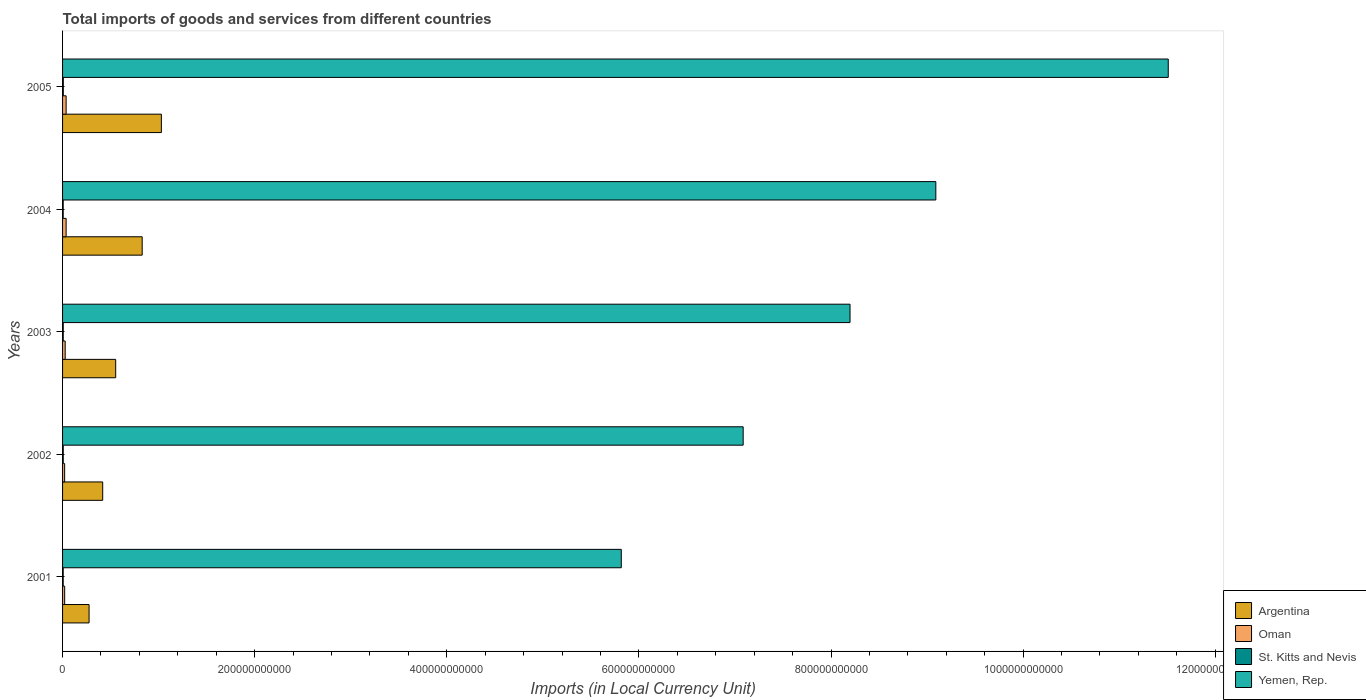How many groups of bars are there?
Provide a succinct answer. 5. How many bars are there on the 5th tick from the top?
Keep it short and to the point. 4. What is the label of the 4th group of bars from the top?
Ensure brevity in your answer.  2002. What is the Amount of goods and services imports in Argentina in 2003?
Make the answer very short. 5.53e+1. Across all years, what is the maximum Amount of goods and services imports in Argentina?
Keep it short and to the point. 1.03e+11. Across all years, what is the minimum Amount of goods and services imports in St. Kitts and Nevis?
Your response must be concise. 6.52e+08. In which year was the Amount of goods and services imports in Oman maximum?
Your answer should be very brief. 2005. In which year was the Amount of goods and services imports in Yemen, Rep. minimum?
Make the answer very short. 2001. What is the total Amount of goods and services imports in Oman in the graph?
Your answer should be compact. 1.45e+1. What is the difference between the Amount of goods and services imports in Oman in 2003 and that in 2005?
Offer a very short reply. -9.84e+08. What is the difference between the Amount of goods and services imports in Oman in 2005 and the Amount of goods and services imports in Argentina in 2003?
Your answer should be very brief. -5.16e+1. What is the average Amount of goods and services imports in St. Kitts and Nevis per year?
Your answer should be very brief. 6.89e+08. In the year 2004, what is the difference between the Amount of goods and services imports in Oman and Amount of goods and services imports in Argentina?
Ensure brevity in your answer.  -7.92e+1. In how many years, is the Amount of goods and services imports in Argentina greater than 560000000000 LCU?
Your answer should be compact. 0. What is the ratio of the Amount of goods and services imports in Oman in 2001 to that in 2003?
Provide a short and direct response. 0.8. What is the difference between the highest and the second highest Amount of goods and services imports in Oman?
Give a very brief answer. 1.10e+07. What is the difference between the highest and the lowest Amount of goods and services imports in Oman?
Give a very brief answer. 1.55e+09. Is it the case that in every year, the sum of the Amount of goods and services imports in Argentina and Amount of goods and services imports in Oman is greater than the sum of Amount of goods and services imports in Yemen, Rep. and Amount of goods and services imports in St. Kitts and Nevis?
Offer a very short reply. No. What does the 1st bar from the top in 2004 represents?
Provide a short and direct response. Yemen, Rep. What does the 4th bar from the bottom in 2004 represents?
Your answer should be compact. Yemen, Rep. Is it the case that in every year, the sum of the Amount of goods and services imports in Argentina and Amount of goods and services imports in St. Kitts and Nevis is greater than the Amount of goods and services imports in Oman?
Keep it short and to the point. Yes. How many bars are there?
Your answer should be very brief. 20. What is the difference between two consecutive major ticks on the X-axis?
Ensure brevity in your answer.  2.00e+11. Are the values on the major ticks of X-axis written in scientific E-notation?
Your answer should be compact. No. How many legend labels are there?
Your answer should be very brief. 4. How are the legend labels stacked?
Your answer should be compact. Vertical. What is the title of the graph?
Your response must be concise. Total imports of goods and services from different countries. Does "Philippines" appear as one of the legend labels in the graph?
Give a very brief answer. No. What is the label or title of the X-axis?
Your response must be concise. Imports (in Local Currency Unit). What is the Imports (in Local Currency Unit) of Argentina in 2001?
Provide a short and direct response. 2.76e+1. What is the Imports (in Local Currency Unit) of Oman in 2001?
Your answer should be compact. 2.19e+09. What is the Imports (in Local Currency Unit) in St. Kitts and Nevis in 2001?
Keep it short and to the point. 6.53e+08. What is the Imports (in Local Currency Unit) in Yemen, Rep. in 2001?
Your answer should be very brief. 5.82e+11. What is the Imports (in Local Currency Unit) of Argentina in 2002?
Make the answer very short. 4.18e+1. What is the Imports (in Local Currency Unit) of Oman in 2002?
Ensure brevity in your answer.  2.16e+09. What is the Imports (in Local Currency Unit) in St. Kitts and Nevis in 2002?
Your answer should be compact. 6.92e+08. What is the Imports (in Local Currency Unit) of Yemen, Rep. in 2002?
Your response must be concise. 7.09e+11. What is the Imports (in Local Currency Unit) of Argentina in 2003?
Your answer should be compact. 5.53e+1. What is the Imports (in Local Currency Unit) in Oman in 2003?
Keep it short and to the point. 2.73e+09. What is the Imports (in Local Currency Unit) in St. Kitts and Nevis in 2003?
Ensure brevity in your answer.  6.91e+08. What is the Imports (in Local Currency Unit) of Yemen, Rep. in 2003?
Your response must be concise. 8.20e+11. What is the Imports (in Local Currency Unit) of Argentina in 2004?
Your answer should be very brief. 8.29e+1. What is the Imports (in Local Currency Unit) of Oman in 2004?
Your response must be concise. 3.70e+09. What is the Imports (in Local Currency Unit) of St. Kitts and Nevis in 2004?
Make the answer very short. 6.52e+08. What is the Imports (in Local Currency Unit) of Yemen, Rep. in 2004?
Your answer should be very brief. 9.09e+11. What is the Imports (in Local Currency Unit) of Argentina in 2005?
Provide a succinct answer. 1.03e+11. What is the Imports (in Local Currency Unit) in Oman in 2005?
Your answer should be very brief. 3.71e+09. What is the Imports (in Local Currency Unit) in St. Kitts and Nevis in 2005?
Offer a very short reply. 7.56e+08. What is the Imports (in Local Currency Unit) in Yemen, Rep. in 2005?
Keep it short and to the point. 1.15e+12. Across all years, what is the maximum Imports (in Local Currency Unit) of Argentina?
Your answer should be very brief. 1.03e+11. Across all years, what is the maximum Imports (in Local Currency Unit) in Oman?
Your response must be concise. 3.71e+09. Across all years, what is the maximum Imports (in Local Currency Unit) of St. Kitts and Nevis?
Provide a succinct answer. 7.56e+08. Across all years, what is the maximum Imports (in Local Currency Unit) of Yemen, Rep.?
Your response must be concise. 1.15e+12. Across all years, what is the minimum Imports (in Local Currency Unit) in Argentina?
Give a very brief answer. 2.76e+1. Across all years, what is the minimum Imports (in Local Currency Unit) in Oman?
Your answer should be compact. 2.16e+09. Across all years, what is the minimum Imports (in Local Currency Unit) in St. Kitts and Nevis?
Provide a succinct answer. 6.52e+08. Across all years, what is the minimum Imports (in Local Currency Unit) of Yemen, Rep.?
Your answer should be very brief. 5.82e+11. What is the total Imports (in Local Currency Unit) in Argentina in the graph?
Give a very brief answer. 3.10e+11. What is the total Imports (in Local Currency Unit) of Oman in the graph?
Make the answer very short. 1.45e+1. What is the total Imports (in Local Currency Unit) in St. Kitts and Nevis in the graph?
Keep it short and to the point. 3.44e+09. What is the total Imports (in Local Currency Unit) in Yemen, Rep. in the graph?
Give a very brief answer. 4.17e+12. What is the difference between the Imports (in Local Currency Unit) in Argentina in 2001 and that in 2002?
Make the answer very short. -1.42e+1. What is the difference between the Imports (in Local Currency Unit) in Oman in 2001 and that in 2002?
Your answer should be compact. 3.20e+07. What is the difference between the Imports (in Local Currency Unit) in St. Kitts and Nevis in 2001 and that in 2002?
Your response must be concise. -3.91e+07. What is the difference between the Imports (in Local Currency Unit) of Yemen, Rep. in 2001 and that in 2002?
Provide a short and direct response. -1.27e+11. What is the difference between the Imports (in Local Currency Unit) of Argentina in 2001 and that in 2003?
Your answer should be very brief. -2.77e+1. What is the difference between the Imports (in Local Currency Unit) of Oman in 2001 and that in 2003?
Provide a short and direct response. -5.34e+08. What is the difference between the Imports (in Local Currency Unit) in St. Kitts and Nevis in 2001 and that in 2003?
Provide a succinct answer. -3.78e+07. What is the difference between the Imports (in Local Currency Unit) in Yemen, Rep. in 2001 and that in 2003?
Keep it short and to the point. -2.38e+11. What is the difference between the Imports (in Local Currency Unit) of Argentina in 2001 and that in 2004?
Your answer should be very brief. -5.53e+1. What is the difference between the Imports (in Local Currency Unit) of Oman in 2001 and that in 2004?
Your answer should be compact. -1.51e+09. What is the difference between the Imports (in Local Currency Unit) in St. Kitts and Nevis in 2001 and that in 2004?
Your response must be concise. 3.97e+05. What is the difference between the Imports (in Local Currency Unit) of Yemen, Rep. in 2001 and that in 2004?
Give a very brief answer. -3.27e+11. What is the difference between the Imports (in Local Currency Unit) of Argentina in 2001 and that in 2005?
Your answer should be very brief. -7.53e+1. What is the difference between the Imports (in Local Currency Unit) of Oman in 2001 and that in 2005?
Provide a succinct answer. -1.52e+09. What is the difference between the Imports (in Local Currency Unit) in St. Kitts and Nevis in 2001 and that in 2005?
Your response must be concise. -1.03e+08. What is the difference between the Imports (in Local Currency Unit) of Yemen, Rep. in 2001 and that in 2005?
Provide a short and direct response. -5.69e+11. What is the difference between the Imports (in Local Currency Unit) of Argentina in 2002 and that in 2003?
Give a very brief answer. -1.35e+1. What is the difference between the Imports (in Local Currency Unit) in Oman in 2002 and that in 2003?
Your response must be concise. -5.66e+08. What is the difference between the Imports (in Local Currency Unit) in St. Kitts and Nevis in 2002 and that in 2003?
Provide a succinct answer. 1.28e+06. What is the difference between the Imports (in Local Currency Unit) of Yemen, Rep. in 2002 and that in 2003?
Keep it short and to the point. -1.11e+11. What is the difference between the Imports (in Local Currency Unit) of Argentina in 2002 and that in 2004?
Your answer should be compact. -4.11e+1. What is the difference between the Imports (in Local Currency Unit) in Oman in 2002 and that in 2004?
Offer a very short reply. -1.54e+09. What is the difference between the Imports (in Local Currency Unit) of St. Kitts and Nevis in 2002 and that in 2004?
Ensure brevity in your answer.  3.95e+07. What is the difference between the Imports (in Local Currency Unit) in Yemen, Rep. in 2002 and that in 2004?
Provide a short and direct response. -2.01e+11. What is the difference between the Imports (in Local Currency Unit) in Argentina in 2002 and that in 2005?
Your response must be concise. -6.11e+1. What is the difference between the Imports (in Local Currency Unit) in Oman in 2002 and that in 2005?
Provide a succinct answer. -1.55e+09. What is the difference between the Imports (in Local Currency Unit) of St. Kitts and Nevis in 2002 and that in 2005?
Your answer should be very brief. -6.44e+07. What is the difference between the Imports (in Local Currency Unit) of Yemen, Rep. in 2002 and that in 2005?
Keep it short and to the point. -4.43e+11. What is the difference between the Imports (in Local Currency Unit) of Argentina in 2003 and that in 2004?
Your answer should be compact. -2.76e+1. What is the difference between the Imports (in Local Currency Unit) of Oman in 2003 and that in 2004?
Offer a very short reply. -9.73e+08. What is the difference between the Imports (in Local Currency Unit) of St. Kitts and Nevis in 2003 and that in 2004?
Your answer should be compact. 3.82e+07. What is the difference between the Imports (in Local Currency Unit) in Yemen, Rep. in 2003 and that in 2004?
Ensure brevity in your answer.  -8.93e+1. What is the difference between the Imports (in Local Currency Unit) in Argentina in 2003 and that in 2005?
Provide a succinct answer. -4.76e+1. What is the difference between the Imports (in Local Currency Unit) of Oman in 2003 and that in 2005?
Give a very brief answer. -9.84e+08. What is the difference between the Imports (in Local Currency Unit) in St. Kitts and Nevis in 2003 and that in 2005?
Provide a short and direct response. -6.57e+07. What is the difference between the Imports (in Local Currency Unit) of Yemen, Rep. in 2003 and that in 2005?
Ensure brevity in your answer.  -3.31e+11. What is the difference between the Imports (in Local Currency Unit) of Argentina in 2004 and that in 2005?
Provide a succinct answer. -2.00e+1. What is the difference between the Imports (in Local Currency Unit) in Oman in 2004 and that in 2005?
Ensure brevity in your answer.  -1.10e+07. What is the difference between the Imports (in Local Currency Unit) in St. Kitts and Nevis in 2004 and that in 2005?
Keep it short and to the point. -1.04e+08. What is the difference between the Imports (in Local Currency Unit) in Yemen, Rep. in 2004 and that in 2005?
Your answer should be very brief. -2.42e+11. What is the difference between the Imports (in Local Currency Unit) of Argentina in 2001 and the Imports (in Local Currency Unit) of Oman in 2002?
Provide a succinct answer. 2.54e+1. What is the difference between the Imports (in Local Currency Unit) of Argentina in 2001 and the Imports (in Local Currency Unit) of St. Kitts and Nevis in 2002?
Make the answer very short. 2.69e+1. What is the difference between the Imports (in Local Currency Unit) in Argentina in 2001 and the Imports (in Local Currency Unit) in Yemen, Rep. in 2002?
Ensure brevity in your answer.  -6.81e+11. What is the difference between the Imports (in Local Currency Unit) of Oman in 2001 and the Imports (in Local Currency Unit) of St. Kitts and Nevis in 2002?
Make the answer very short. 1.50e+09. What is the difference between the Imports (in Local Currency Unit) in Oman in 2001 and the Imports (in Local Currency Unit) in Yemen, Rep. in 2002?
Offer a very short reply. -7.06e+11. What is the difference between the Imports (in Local Currency Unit) of St. Kitts and Nevis in 2001 and the Imports (in Local Currency Unit) of Yemen, Rep. in 2002?
Your answer should be very brief. -7.08e+11. What is the difference between the Imports (in Local Currency Unit) in Argentina in 2001 and the Imports (in Local Currency Unit) in Oman in 2003?
Make the answer very short. 2.49e+1. What is the difference between the Imports (in Local Currency Unit) in Argentina in 2001 and the Imports (in Local Currency Unit) in St. Kitts and Nevis in 2003?
Your response must be concise. 2.69e+1. What is the difference between the Imports (in Local Currency Unit) in Argentina in 2001 and the Imports (in Local Currency Unit) in Yemen, Rep. in 2003?
Ensure brevity in your answer.  -7.92e+11. What is the difference between the Imports (in Local Currency Unit) in Oman in 2001 and the Imports (in Local Currency Unit) in St. Kitts and Nevis in 2003?
Offer a terse response. 1.50e+09. What is the difference between the Imports (in Local Currency Unit) in Oman in 2001 and the Imports (in Local Currency Unit) in Yemen, Rep. in 2003?
Your response must be concise. -8.18e+11. What is the difference between the Imports (in Local Currency Unit) in St. Kitts and Nevis in 2001 and the Imports (in Local Currency Unit) in Yemen, Rep. in 2003?
Give a very brief answer. -8.19e+11. What is the difference between the Imports (in Local Currency Unit) of Argentina in 2001 and the Imports (in Local Currency Unit) of Oman in 2004?
Your answer should be very brief. 2.39e+1. What is the difference between the Imports (in Local Currency Unit) of Argentina in 2001 and the Imports (in Local Currency Unit) of St. Kitts and Nevis in 2004?
Provide a succinct answer. 2.70e+1. What is the difference between the Imports (in Local Currency Unit) in Argentina in 2001 and the Imports (in Local Currency Unit) in Yemen, Rep. in 2004?
Your answer should be compact. -8.82e+11. What is the difference between the Imports (in Local Currency Unit) of Oman in 2001 and the Imports (in Local Currency Unit) of St. Kitts and Nevis in 2004?
Your answer should be compact. 1.54e+09. What is the difference between the Imports (in Local Currency Unit) of Oman in 2001 and the Imports (in Local Currency Unit) of Yemen, Rep. in 2004?
Give a very brief answer. -9.07e+11. What is the difference between the Imports (in Local Currency Unit) of St. Kitts and Nevis in 2001 and the Imports (in Local Currency Unit) of Yemen, Rep. in 2004?
Keep it short and to the point. -9.08e+11. What is the difference between the Imports (in Local Currency Unit) of Argentina in 2001 and the Imports (in Local Currency Unit) of Oman in 2005?
Provide a succinct answer. 2.39e+1. What is the difference between the Imports (in Local Currency Unit) of Argentina in 2001 and the Imports (in Local Currency Unit) of St. Kitts and Nevis in 2005?
Your answer should be very brief. 2.68e+1. What is the difference between the Imports (in Local Currency Unit) in Argentina in 2001 and the Imports (in Local Currency Unit) in Yemen, Rep. in 2005?
Your answer should be very brief. -1.12e+12. What is the difference between the Imports (in Local Currency Unit) in Oman in 2001 and the Imports (in Local Currency Unit) in St. Kitts and Nevis in 2005?
Your answer should be very brief. 1.44e+09. What is the difference between the Imports (in Local Currency Unit) in Oman in 2001 and the Imports (in Local Currency Unit) in Yemen, Rep. in 2005?
Keep it short and to the point. -1.15e+12. What is the difference between the Imports (in Local Currency Unit) of St. Kitts and Nevis in 2001 and the Imports (in Local Currency Unit) of Yemen, Rep. in 2005?
Offer a terse response. -1.15e+12. What is the difference between the Imports (in Local Currency Unit) of Argentina in 2002 and the Imports (in Local Currency Unit) of Oman in 2003?
Make the answer very short. 3.91e+1. What is the difference between the Imports (in Local Currency Unit) of Argentina in 2002 and the Imports (in Local Currency Unit) of St. Kitts and Nevis in 2003?
Offer a very short reply. 4.11e+1. What is the difference between the Imports (in Local Currency Unit) of Argentina in 2002 and the Imports (in Local Currency Unit) of Yemen, Rep. in 2003?
Ensure brevity in your answer.  -7.78e+11. What is the difference between the Imports (in Local Currency Unit) of Oman in 2002 and the Imports (in Local Currency Unit) of St. Kitts and Nevis in 2003?
Your answer should be very brief. 1.47e+09. What is the difference between the Imports (in Local Currency Unit) of Oman in 2002 and the Imports (in Local Currency Unit) of Yemen, Rep. in 2003?
Offer a terse response. -8.18e+11. What is the difference between the Imports (in Local Currency Unit) in St. Kitts and Nevis in 2002 and the Imports (in Local Currency Unit) in Yemen, Rep. in 2003?
Your answer should be very brief. -8.19e+11. What is the difference between the Imports (in Local Currency Unit) in Argentina in 2002 and the Imports (in Local Currency Unit) in Oman in 2004?
Keep it short and to the point. 3.81e+1. What is the difference between the Imports (in Local Currency Unit) of Argentina in 2002 and the Imports (in Local Currency Unit) of St. Kitts and Nevis in 2004?
Offer a very short reply. 4.11e+1. What is the difference between the Imports (in Local Currency Unit) of Argentina in 2002 and the Imports (in Local Currency Unit) of Yemen, Rep. in 2004?
Offer a terse response. -8.67e+11. What is the difference between the Imports (in Local Currency Unit) in Oman in 2002 and the Imports (in Local Currency Unit) in St. Kitts and Nevis in 2004?
Provide a short and direct response. 1.51e+09. What is the difference between the Imports (in Local Currency Unit) of Oman in 2002 and the Imports (in Local Currency Unit) of Yemen, Rep. in 2004?
Offer a very short reply. -9.07e+11. What is the difference between the Imports (in Local Currency Unit) in St. Kitts and Nevis in 2002 and the Imports (in Local Currency Unit) in Yemen, Rep. in 2004?
Offer a terse response. -9.08e+11. What is the difference between the Imports (in Local Currency Unit) in Argentina in 2002 and the Imports (in Local Currency Unit) in Oman in 2005?
Your answer should be very brief. 3.81e+1. What is the difference between the Imports (in Local Currency Unit) of Argentina in 2002 and the Imports (in Local Currency Unit) of St. Kitts and Nevis in 2005?
Make the answer very short. 4.10e+1. What is the difference between the Imports (in Local Currency Unit) in Argentina in 2002 and the Imports (in Local Currency Unit) in Yemen, Rep. in 2005?
Make the answer very short. -1.11e+12. What is the difference between the Imports (in Local Currency Unit) of Oman in 2002 and the Imports (in Local Currency Unit) of St. Kitts and Nevis in 2005?
Provide a short and direct response. 1.41e+09. What is the difference between the Imports (in Local Currency Unit) of Oman in 2002 and the Imports (in Local Currency Unit) of Yemen, Rep. in 2005?
Offer a very short reply. -1.15e+12. What is the difference between the Imports (in Local Currency Unit) of St. Kitts and Nevis in 2002 and the Imports (in Local Currency Unit) of Yemen, Rep. in 2005?
Your answer should be very brief. -1.15e+12. What is the difference between the Imports (in Local Currency Unit) in Argentina in 2003 and the Imports (in Local Currency Unit) in Oman in 2004?
Provide a succinct answer. 5.16e+1. What is the difference between the Imports (in Local Currency Unit) of Argentina in 2003 and the Imports (in Local Currency Unit) of St. Kitts and Nevis in 2004?
Offer a terse response. 5.47e+1. What is the difference between the Imports (in Local Currency Unit) in Argentina in 2003 and the Imports (in Local Currency Unit) in Yemen, Rep. in 2004?
Your response must be concise. -8.54e+11. What is the difference between the Imports (in Local Currency Unit) in Oman in 2003 and the Imports (in Local Currency Unit) in St. Kitts and Nevis in 2004?
Ensure brevity in your answer.  2.08e+09. What is the difference between the Imports (in Local Currency Unit) of Oman in 2003 and the Imports (in Local Currency Unit) of Yemen, Rep. in 2004?
Make the answer very short. -9.06e+11. What is the difference between the Imports (in Local Currency Unit) of St. Kitts and Nevis in 2003 and the Imports (in Local Currency Unit) of Yemen, Rep. in 2004?
Provide a short and direct response. -9.08e+11. What is the difference between the Imports (in Local Currency Unit) in Argentina in 2003 and the Imports (in Local Currency Unit) in Oman in 2005?
Offer a very short reply. 5.16e+1. What is the difference between the Imports (in Local Currency Unit) in Argentina in 2003 and the Imports (in Local Currency Unit) in St. Kitts and Nevis in 2005?
Make the answer very short. 5.46e+1. What is the difference between the Imports (in Local Currency Unit) in Argentina in 2003 and the Imports (in Local Currency Unit) in Yemen, Rep. in 2005?
Keep it short and to the point. -1.10e+12. What is the difference between the Imports (in Local Currency Unit) of Oman in 2003 and the Imports (in Local Currency Unit) of St. Kitts and Nevis in 2005?
Offer a terse response. 1.97e+09. What is the difference between the Imports (in Local Currency Unit) of Oman in 2003 and the Imports (in Local Currency Unit) of Yemen, Rep. in 2005?
Provide a succinct answer. -1.15e+12. What is the difference between the Imports (in Local Currency Unit) in St. Kitts and Nevis in 2003 and the Imports (in Local Currency Unit) in Yemen, Rep. in 2005?
Your answer should be compact. -1.15e+12. What is the difference between the Imports (in Local Currency Unit) of Argentina in 2004 and the Imports (in Local Currency Unit) of Oman in 2005?
Provide a short and direct response. 7.92e+1. What is the difference between the Imports (in Local Currency Unit) in Argentina in 2004 and the Imports (in Local Currency Unit) in St. Kitts and Nevis in 2005?
Keep it short and to the point. 8.21e+1. What is the difference between the Imports (in Local Currency Unit) in Argentina in 2004 and the Imports (in Local Currency Unit) in Yemen, Rep. in 2005?
Your response must be concise. -1.07e+12. What is the difference between the Imports (in Local Currency Unit) in Oman in 2004 and the Imports (in Local Currency Unit) in St. Kitts and Nevis in 2005?
Provide a succinct answer. 2.94e+09. What is the difference between the Imports (in Local Currency Unit) of Oman in 2004 and the Imports (in Local Currency Unit) of Yemen, Rep. in 2005?
Your response must be concise. -1.15e+12. What is the difference between the Imports (in Local Currency Unit) of St. Kitts and Nevis in 2004 and the Imports (in Local Currency Unit) of Yemen, Rep. in 2005?
Provide a short and direct response. -1.15e+12. What is the average Imports (in Local Currency Unit) in Argentina per year?
Offer a terse response. 6.21e+1. What is the average Imports (in Local Currency Unit) of Oman per year?
Give a very brief answer. 2.90e+09. What is the average Imports (in Local Currency Unit) of St. Kitts and Nevis per year?
Your answer should be very brief. 6.89e+08. What is the average Imports (in Local Currency Unit) in Yemen, Rep. per year?
Offer a terse response. 8.34e+11. In the year 2001, what is the difference between the Imports (in Local Currency Unit) in Argentina and Imports (in Local Currency Unit) in Oman?
Keep it short and to the point. 2.54e+1. In the year 2001, what is the difference between the Imports (in Local Currency Unit) of Argentina and Imports (in Local Currency Unit) of St. Kitts and Nevis?
Your answer should be compact. 2.70e+1. In the year 2001, what is the difference between the Imports (in Local Currency Unit) in Argentina and Imports (in Local Currency Unit) in Yemen, Rep.?
Your answer should be compact. -5.54e+11. In the year 2001, what is the difference between the Imports (in Local Currency Unit) of Oman and Imports (in Local Currency Unit) of St. Kitts and Nevis?
Your answer should be compact. 1.54e+09. In the year 2001, what is the difference between the Imports (in Local Currency Unit) of Oman and Imports (in Local Currency Unit) of Yemen, Rep.?
Your response must be concise. -5.79e+11. In the year 2001, what is the difference between the Imports (in Local Currency Unit) of St. Kitts and Nevis and Imports (in Local Currency Unit) of Yemen, Rep.?
Provide a succinct answer. -5.81e+11. In the year 2002, what is the difference between the Imports (in Local Currency Unit) in Argentina and Imports (in Local Currency Unit) in Oman?
Ensure brevity in your answer.  3.96e+1. In the year 2002, what is the difference between the Imports (in Local Currency Unit) of Argentina and Imports (in Local Currency Unit) of St. Kitts and Nevis?
Offer a very short reply. 4.11e+1. In the year 2002, what is the difference between the Imports (in Local Currency Unit) in Argentina and Imports (in Local Currency Unit) in Yemen, Rep.?
Offer a terse response. -6.67e+11. In the year 2002, what is the difference between the Imports (in Local Currency Unit) of Oman and Imports (in Local Currency Unit) of St. Kitts and Nevis?
Provide a short and direct response. 1.47e+09. In the year 2002, what is the difference between the Imports (in Local Currency Unit) of Oman and Imports (in Local Currency Unit) of Yemen, Rep.?
Your response must be concise. -7.06e+11. In the year 2002, what is the difference between the Imports (in Local Currency Unit) of St. Kitts and Nevis and Imports (in Local Currency Unit) of Yemen, Rep.?
Give a very brief answer. -7.08e+11. In the year 2003, what is the difference between the Imports (in Local Currency Unit) of Argentina and Imports (in Local Currency Unit) of Oman?
Offer a very short reply. 5.26e+1. In the year 2003, what is the difference between the Imports (in Local Currency Unit) of Argentina and Imports (in Local Currency Unit) of St. Kitts and Nevis?
Your answer should be compact. 5.46e+1. In the year 2003, what is the difference between the Imports (in Local Currency Unit) of Argentina and Imports (in Local Currency Unit) of Yemen, Rep.?
Keep it short and to the point. -7.65e+11. In the year 2003, what is the difference between the Imports (in Local Currency Unit) in Oman and Imports (in Local Currency Unit) in St. Kitts and Nevis?
Your response must be concise. 2.04e+09. In the year 2003, what is the difference between the Imports (in Local Currency Unit) of Oman and Imports (in Local Currency Unit) of Yemen, Rep.?
Provide a short and direct response. -8.17e+11. In the year 2003, what is the difference between the Imports (in Local Currency Unit) in St. Kitts and Nevis and Imports (in Local Currency Unit) in Yemen, Rep.?
Your answer should be very brief. -8.19e+11. In the year 2004, what is the difference between the Imports (in Local Currency Unit) of Argentina and Imports (in Local Currency Unit) of Oman?
Your response must be concise. 7.92e+1. In the year 2004, what is the difference between the Imports (in Local Currency Unit) in Argentina and Imports (in Local Currency Unit) in St. Kitts and Nevis?
Offer a terse response. 8.22e+1. In the year 2004, what is the difference between the Imports (in Local Currency Unit) in Argentina and Imports (in Local Currency Unit) in Yemen, Rep.?
Ensure brevity in your answer.  -8.26e+11. In the year 2004, what is the difference between the Imports (in Local Currency Unit) in Oman and Imports (in Local Currency Unit) in St. Kitts and Nevis?
Provide a short and direct response. 3.05e+09. In the year 2004, what is the difference between the Imports (in Local Currency Unit) in Oman and Imports (in Local Currency Unit) in Yemen, Rep.?
Your answer should be very brief. -9.05e+11. In the year 2004, what is the difference between the Imports (in Local Currency Unit) of St. Kitts and Nevis and Imports (in Local Currency Unit) of Yemen, Rep.?
Your response must be concise. -9.08e+11. In the year 2005, what is the difference between the Imports (in Local Currency Unit) in Argentina and Imports (in Local Currency Unit) in Oman?
Give a very brief answer. 9.92e+1. In the year 2005, what is the difference between the Imports (in Local Currency Unit) of Argentina and Imports (in Local Currency Unit) of St. Kitts and Nevis?
Provide a short and direct response. 1.02e+11. In the year 2005, what is the difference between the Imports (in Local Currency Unit) of Argentina and Imports (in Local Currency Unit) of Yemen, Rep.?
Your answer should be compact. -1.05e+12. In the year 2005, what is the difference between the Imports (in Local Currency Unit) of Oman and Imports (in Local Currency Unit) of St. Kitts and Nevis?
Your answer should be compact. 2.96e+09. In the year 2005, what is the difference between the Imports (in Local Currency Unit) in Oman and Imports (in Local Currency Unit) in Yemen, Rep.?
Ensure brevity in your answer.  -1.15e+12. In the year 2005, what is the difference between the Imports (in Local Currency Unit) in St. Kitts and Nevis and Imports (in Local Currency Unit) in Yemen, Rep.?
Provide a short and direct response. -1.15e+12. What is the ratio of the Imports (in Local Currency Unit) in Argentina in 2001 to that in 2002?
Your response must be concise. 0.66. What is the ratio of the Imports (in Local Currency Unit) of Oman in 2001 to that in 2002?
Keep it short and to the point. 1.01. What is the ratio of the Imports (in Local Currency Unit) in St. Kitts and Nevis in 2001 to that in 2002?
Offer a terse response. 0.94. What is the ratio of the Imports (in Local Currency Unit) in Yemen, Rep. in 2001 to that in 2002?
Make the answer very short. 0.82. What is the ratio of the Imports (in Local Currency Unit) in Argentina in 2001 to that in 2003?
Provide a short and direct response. 0.5. What is the ratio of the Imports (in Local Currency Unit) of Oman in 2001 to that in 2003?
Offer a terse response. 0.8. What is the ratio of the Imports (in Local Currency Unit) in St. Kitts and Nevis in 2001 to that in 2003?
Give a very brief answer. 0.95. What is the ratio of the Imports (in Local Currency Unit) in Yemen, Rep. in 2001 to that in 2003?
Offer a terse response. 0.71. What is the ratio of the Imports (in Local Currency Unit) in Argentina in 2001 to that in 2004?
Offer a terse response. 0.33. What is the ratio of the Imports (in Local Currency Unit) in Oman in 2001 to that in 2004?
Ensure brevity in your answer.  0.59. What is the ratio of the Imports (in Local Currency Unit) of Yemen, Rep. in 2001 to that in 2004?
Ensure brevity in your answer.  0.64. What is the ratio of the Imports (in Local Currency Unit) in Argentina in 2001 to that in 2005?
Your answer should be very brief. 0.27. What is the ratio of the Imports (in Local Currency Unit) of Oman in 2001 to that in 2005?
Provide a short and direct response. 0.59. What is the ratio of the Imports (in Local Currency Unit) of St. Kitts and Nevis in 2001 to that in 2005?
Keep it short and to the point. 0.86. What is the ratio of the Imports (in Local Currency Unit) in Yemen, Rep. in 2001 to that in 2005?
Your answer should be very brief. 0.51. What is the ratio of the Imports (in Local Currency Unit) in Argentina in 2002 to that in 2003?
Give a very brief answer. 0.76. What is the ratio of the Imports (in Local Currency Unit) of Oman in 2002 to that in 2003?
Give a very brief answer. 0.79. What is the ratio of the Imports (in Local Currency Unit) in Yemen, Rep. in 2002 to that in 2003?
Make the answer very short. 0.86. What is the ratio of the Imports (in Local Currency Unit) in Argentina in 2002 to that in 2004?
Your response must be concise. 0.5. What is the ratio of the Imports (in Local Currency Unit) of Oman in 2002 to that in 2004?
Make the answer very short. 0.58. What is the ratio of the Imports (in Local Currency Unit) in St. Kitts and Nevis in 2002 to that in 2004?
Keep it short and to the point. 1.06. What is the ratio of the Imports (in Local Currency Unit) in Yemen, Rep. in 2002 to that in 2004?
Provide a short and direct response. 0.78. What is the ratio of the Imports (in Local Currency Unit) in Argentina in 2002 to that in 2005?
Your response must be concise. 0.41. What is the ratio of the Imports (in Local Currency Unit) in Oman in 2002 to that in 2005?
Ensure brevity in your answer.  0.58. What is the ratio of the Imports (in Local Currency Unit) in St. Kitts and Nevis in 2002 to that in 2005?
Your answer should be very brief. 0.91. What is the ratio of the Imports (in Local Currency Unit) in Yemen, Rep. in 2002 to that in 2005?
Provide a short and direct response. 0.62. What is the ratio of the Imports (in Local Currency Unit) of Argentina in 2003 to that in 2004?
Offer a very short reply. 0.67. What is the ratio of the Imports (in Local Currency Unit) of Oman in 2003 to that in 2004?
Ensure brevity in your answer.  0.74. What is the ratio of the Imports (in Local Currency Unit) in St. Kitts and Nevis in 2003 to that in 2004?
Offer a terse response. 1.06. What is the ratio of the Imports (in Local Currency Unit) in Yemen, Rep. in 2003 to that in 2004?
Provide a succinct answer. 0.9. What is the ratio of the Imports (in Local Currency Unit) in Argentina in 2003 to that in 2005?
Your response must be concise. 0.54. What is the ratio of the Imports (in Local Currency Unit) in Oman in 2003 to that in 2005?
Give a very brief answer. 0.73. What is the ratio of the Imports (in Local Currency Unit) of St. Kitts and Nevis in 2003 to that in 2005?
Provide a succinct answer. 0.91. What is the ratio of the Imports (in Local Currency Unit) of Yemen, Rep. in 2003 to that in 2005?
Make the answer very short. 0.71. What is the ratio of the Imports (in Local Currency Unit) of Argentina in 2004 to that in 2005?
Provide a succinct answer. 0.81. What is the ratio of the Imports (in Local Currency Unit) in Oman in 2004 to that in 2005?
Provide a short and direct response. 1. What is the ratio of the Imports (in Local Currency Unit) of St. Kitts and Nevis in 2004 to that in 2005?
Ensure brevity in your answer.  0.86. What is the ratio of the Imports (in Local Currency Unit) of Yemen, Rep. in 2004 to that in 2005?
Provide a short and direct response. 0.79. What is the difference between the highest and the second highest Imports (in Local Currency Unit) in Argentina?
Offer a very short reply. 2.00e+1. What is the difference between the highest and the second highest Imports (in Local Currency Unit) in Oman?
Ensure brevity in your answer.  1.10e+07. What is the difference between the highest and the second highest Imports (in Local Currency Unit) in St. Kitts and Nevis?
Provide a short and direct response. 6.44e+07. What is the difference between the highest and the second highest Imports (in Local Currency Unit) of Yemen, Rep.?
Give a very brief answer. 2.42e+11. What is the difference between the highest and the lowest Imports (in Local Currency Unit) of Argentina?
Give a very brief answer. 7.53e+1. What is the difference between the highest and the lowest Imports (in Local Currency Unit) of Oman?
Make the answer very short. 1.55e+09. What is the difference between the highest and the lowest Imports (in Local Currency Unit) in St. Kitts and Nevis?
Your answer should be very brief. 1.04e+08. What is the difference between the highest and the lowest Imports (in Local Currency Unit) of Yemen, Rep.?
Provide a short and direct response. 5.69e+11. 